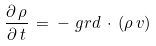Convert formula to latex. <formula><loc_0><loc_0><loc_500><loc_500>\frac { \partial \, \rho } { \partial \, t } \, = \, - \ g r d \, \cdot \, ( \rho \, { v } )</formula> 